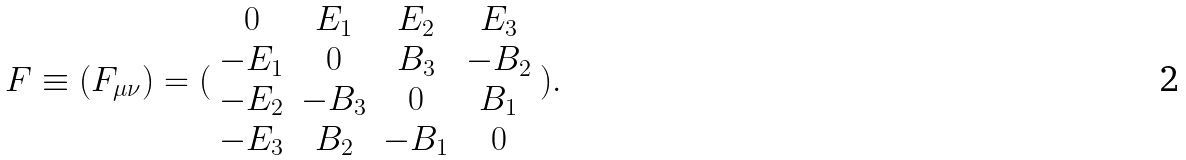<formula> <loc_0><loc_0><loc_500><loc_500>F \equiv ( F _ { \mu \nu } ) = ( \begin{array} { c c c c } 0 & E _ { 1 } & E _ { 2 } & E _ { 3 } \\ - E _ { 1 } & 0 & B _ { 3 } & - B _ { 2 } \\ - E _ { 2 } & - B _ { 3 } & 0 & B _ { 1 } \\ - E _ { 3 } & B _ { 2 } & - B _ { 1 } & 0 \end{array} ) .</formula> 